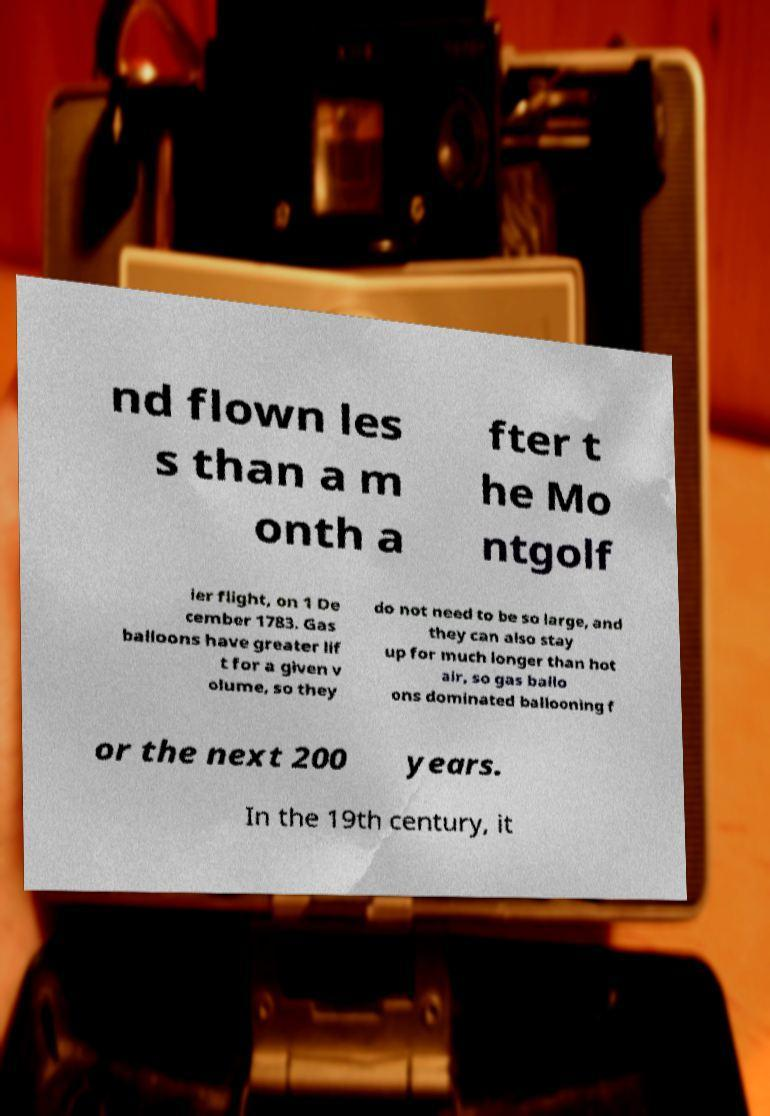Please identify and transcribe the text found in this image. nd flown les s than a m onth a fter t he Mo ntgolf ier flight, on 1 De cember 1783. Gas balloons have greater lif t for a given v olume, so they do not need to be so large, and they can also stay up for much longer than hot air, so gas ballo ons dominated ballooning f or the next 200 years. In the 19th century, it 